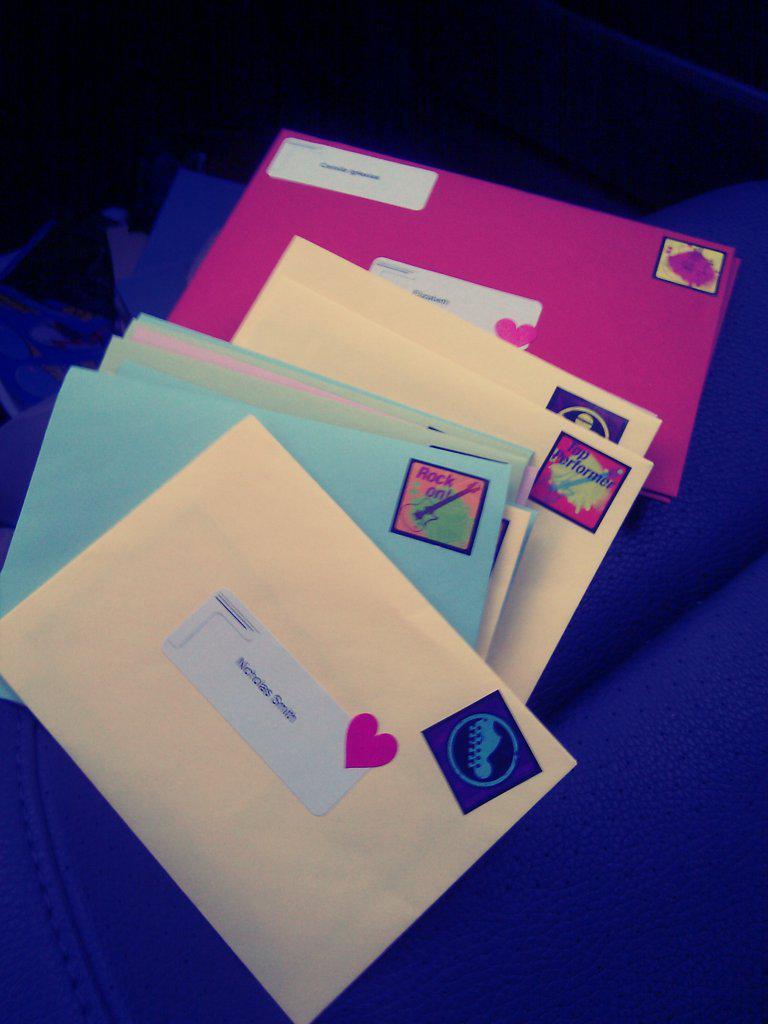How will be receiving the top envelope?
Give a very brief answer. Nicholas smith. 